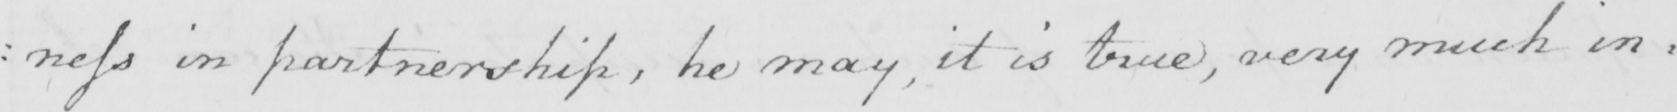What text is written in this handwritten line? : ness in partnership , he may , it is true , very much in= 